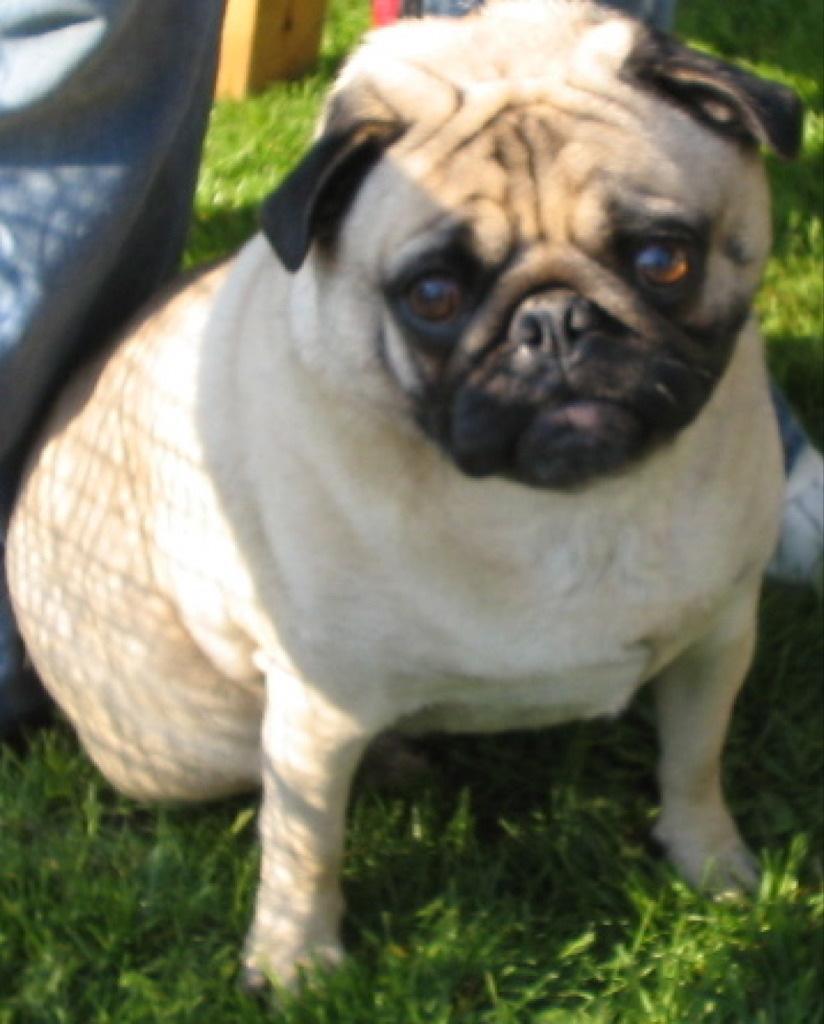Please provide a concise description of this image. In this image there is a dog on a grassland. 